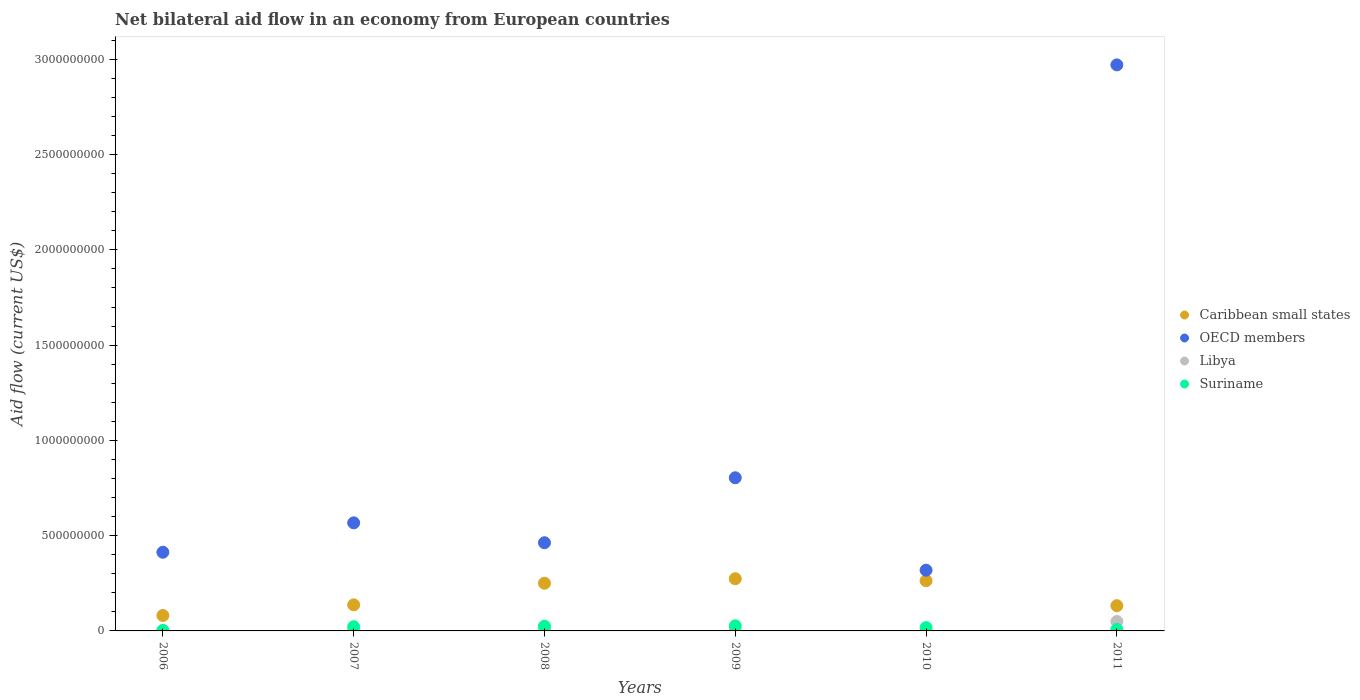How many different coloured dotlines are there?
Ensure brevity in your answer.  4. Is the number of dotlines equal to the number of legend labels?
Provide a succinct answer. Yes. What is the net bilateral aid flow in Libya in 2006?
Offer a very short reply. 8.10e+05. Across all years, what is the maximum net bilateral aid flow in Libya?
Your answer should be compact. 4.94e+07. Across all years, what is the minimum net bilateral aid flow in OECD members?
Provide a succinct answer. 3.19e+08. In which year was the net bilateral aid flow in Libya maximum?
Offer a terse response. 2011. In which year was the net bilateral aid flow in Suriname minimum?
Give a very brief answer. 2006. What is the total net bilateral aid flow in Libya in the graph?
Your answer should be compact. 5.89e+07. What is the difference between the net bilateral aid flow in Caribbean small states in 2007 and that in 2009?
Ensure brevity in your answer.  -1.37e+08. What is the difference between the net bilateral aid flow in Caribbean small states in 2007 and the net bilateral aid flow in Suriname in 2008?
Provide a succinct answer. 1.12e+08. What is the average net bilateral aid flow in Libya per year?
Provide a short and direct response. 9.82e+06. In the year 2007, what is the difference between the net bilateral aid flow in Suriname and net bilateral aid flow in Libya?
Provide a short and direct response. 2.09e+07. What is the ratio of the net bilateral aid flow in Libya in 2006 to that in 2009?
Your answer should be compact. 0.37. Is the net bilateral aid flow in OECD members in 2010 less than that in 2011?
Your answer should be very brief. Yes. Is the difference between the net bilateral aid flow in Suriname in 2008 and 2011 greater than the difference between the net bilateral aid flow in Libya in 2008 and 2011?
Give a very brief answer. Yes. What is the difference between the highest and the second highest net bilateral aid flow in Caribbean small states?
Give a very brief answer. 1.02e+07. What is the difference between the highest and the lowest net bilateral aid flow in Suriname?
Provide a succinct answer. 2.42e+07. Is the sum of the net bilateral aid flow in OECD members in 2007 and 2009 greater than the maximum net bilateral aid flow in Suriname across all years?
Give a very brief answer. Yes. Is it the case that in every year, the sum of the net bilateral aid flow in OECD members and net bilateral aid flow in Libya  is greater than the sum of net bilateral aid flow in Suriname and net bilateral aid flow in Caribbean small states?
Offer a very short reply. Yes. Is the net bilateral aid flow in OECD members strictly less than the net bilateral aid flow in Caribbean small states over the years?
Ensure brevity in your answer.  No. Does the graph contain grids?
Offer a very short reply. No. Where does the legend appear in the graph?
Offer a very short reply. Center right. What is the title of the graph?
Your answer should be very brief. Net bilateral aid flow in an economy from European countries. Does "Europe(all income levels)" appear as one of the legend labels in the graph?
Provide a succinct answer. No. What is the Aid flow (current US$) in Caribbean small states in 2006?
Your answer should be very brief. 8.10e+07. What is the Aid flow (current US$) of OECD members in 2006?
Keep it short and to the point. 4.13e+08. What is the Aid flow (current US$) of Libya in 2006?
Give a very brief answer. 8.10e+05. What is the Aid flow (current US$) in Suriname in 2006?
Your response must be concise. 2.58e+06. What is the Aid flow (current US$) of Caribbean small states in 2007?
Keep it short and to the point. 1.37e+08. What is the Aid flow (current US$) in OECD members in 2007?
Your answer should be compact. 5.67e+08. What is the Aid flow (current US$) in Libya in 2007?
Provide a succinct answer. 1.12e+06. What is the Aid flow (current US$) of Suriname in 2007?
Offer a terse response. 2.20e+07. What is the Aid flow (current US$) of Caribbean small states in 2008?
Offer a very short reply. 2.50e+08. What is the Aid flow (current US$) of OECD members in 2008?
Give a very brief answer. 4.63e+08. What is the Aid flow (current US$) of Libya in 2008?
Your answer should be very brief. 4.29e+06. What is the Aid flow (current US$) in Suriname in 2008?
Your answer should be very brief. 2.47e+07. What is the Aid flow (current US$) in Caribbean small states in 2009?
Offer a terse response. 2.74e+08. What is the Aid flow (current US$) of OECD members in 2009?
Your answer should be very brief. 8.04e+08. What is the Aid flow (current US$) in Libya in 2009?
Offer a very short reply. 2.17e+06. What is the Aid flow (current US$) of Suriname in 2009?
Keep it short and to the point. 2.68e+07. What is the Aid flow (current US$) in Caribbean small states in 2010?
Ensure brevity in your answer.  2.64e+08. What is the Aid flow (current US$) of OECD members in 2010?
Ensure brevity in your answer.  3.19e+08. What is the Aid flow (current US$) in Libya in 2010?
Keep it short and to the point. 1.06e+06. What is the Aid flow (current US$) of Suriname in 2010?
Your answer should be compact. 1.74e+07. What is the Aid flow (current US$) of Caribbean small states in 2011?
Your answer should be very brief. 1.32e+08. What is the Aid flow (current US$) in OECD members in 2011?
Offer a very short reply. 2.97e+09. What is the Aid flow (current US$) of Libya in 2011?
Offer a terse response. 4.94e+07. What is the Aid flow (current US$) of Suriname in 2011?
Keep it short and to the point. 7.56e+06. Across all years, what is the maximum Aid flow (current US$) in Caribbean small states?
Make the answer very short. 2.74e+08. Across all years, what is the maximum Aid flow (current US$) of OECD members?
Provide a succinct answer. 2.97e+09. Across all years, what is the maximum Aid flow (current US$) of Libya?
Offer a very short reply. 4.94e+07. Across all years, what is the maximum Aid flow (current US$) of Suriname?
Give a very brief answer. 2.68e+07. Across all years, what is the minimum Aid flow (current US$) of Caribbean small states?
Your response must be concise. 8.10e+07. Across all years, what is the minimum Aid flow (current US$) of OECD members?
Offer a very short reply. 3.19e+08. Across all years, what is the minimum Aid flow (current US$) of Libya?
Your answer should be very brief. 8.10e+05. Across all years, what is the minimum Aid flow (current US$) in Suriname?
Your answer should be compact. 2.58e+06. What is the total Aid flow (current US$) in Caribbean small states in the graph?
Offer a very short reply. 1.14e+09. What is the total Aid flow (current US$) in OECD members in the graph?
Offer a terse response. 5.54e+09. What is the total Aid flow (current US$) in Libya in the graph?
Offer a terse response. 5.89e+07. What is the total Aid flow (current US$) of Suriname in the graph?
Ensure brevity in your answer.  1.01e+08. What is the difference between the Aid flow (current US$) in Caribbean small states in 2006 and that in 2007?
Provide a short and direct response. -5.58e+07. What is the difference between the Aid flow (current US$) of OECD members in 2006 and that in 2007?
Offer a terse response. -1.54e+08. What is the difference between the Aid flow (current US$) of Libya in 2006 and that in 2007?
Give a very brief answer. -3.10e+05. What is the difference between the Aid flow (current US$) in Suriname in 2006 and that in 2007?
Provide a succinct answer. -1.95e+07. What is the difference between the Aid flow (current US$) in Caribbean small states in 2006 and that in 2008?
Your answer should be compact. -1.69e+08. What is the difference between the Aid flow (current US$) in OECD members in 2006 and that in 2008?
Your answer should be compact. -4.98e+07. What is the difference between the Aid flow (current US$) of Libya in 2006 and that in 2008?
Ensure brevity in your answer.  -3.48e+06. What is the difference between the Aid flow (current US$) of Suriname in 2006 and that in 2008?
Offer a very short reply. -2.21e+07. What is the difference between the Aid flow (current US$) in Caribbean small states in 2006 and that in 2009?
Your response must be concise. -1.93e+08. What is the difference between the Aid flow (current US$) of OECD members in 2006 and that in 2009?
Your response must be concise. -3.91e+08. What is the difference between the Aid flow (current US$) of Libya in 2006 and that in 2009?
Your answer should be very brief. -1.36e+06. What is the difference between the Aid flow (current US$) of Suriname in 2006 and that in 2009?
Make the answer very short. -2.42e+07. What is the difference between the Aid flow (current US$) in Caribbean small states in 2006 and that in 2010?
Your answer should be very brief. -1.83e+08. What is the difference between the Aid flow (current US$) in OECD members in 2006 and that in 2010?
Offer a very short reply. 9.41e+07. What is the difference between the Aid flow (current US$) of Suriname in 2006 and that in 2010?
Ensure brevity in your answer.  -1.48e+07. What is the difference between the Aid flow (current US$) of Caribbean small states in 2006 and that in 2011?
Keep it short and to the point. -5.14e+07. What is the difference between the Aid flow (current US$) in OECD members in 2006 and that in 2011?
Offer a terse response. -2.56e+09. What is the difference between the Aid flow (current US$) in Libya in 2006 and that in 2011?
Ensure brevity in your answer.  -4.86e+07. What is the difference between the Aid flow (current US$) of Suriname in 2006 and that in 2011?
Your answer should be very brief. -4.98e+06. What is the difference between the Aid flow (current US$) of Caribbean small states in 2007 and that in 2008?
Ensure brevity in your answer.  -1.13e+08. What is the difference between the Aid flow (current US$) of OECD members in 2007 and that in 2008?
Provide a succinct answer. 1.04e+08. What is the difference between the Aid flow (current US$) of Libya in 2007 and that in 2008?
Provide a succinct answer. -3.17e+06. What is the difference between the Aid flow (current US$) of Suriname in 2007 and that in 2008?
Your answer should be very brief. -2.66e+06. What is the difference between the Aid flow (current US$) in Caribbean small states in 2007 and that in 2009?
Provide a short and direct response. -1.37e+08. What is the difference between the Aid flow (current US$) of OECD members in 2007 and that in 2009?
Keep it short and to the point. -2.37e+08. What is the difference between the Aid flow (current US$) of Libya in 2007 and that in 2009?
Offer a terse response. -1.05e+06. What is the difference between the Aid flow (current US$) of Suriname in 2007 and that in 2009?
Offer a terse response. -4.75e+06. What is the difference between the Aid flow (current US$) in Caribbean small states in 2007 and that in 2010?
Provide a succinct answer. -1.27e+08. What is the difference between the Aid flow (current US$) of OECD members in 2007 and that in 2010?
Offer a very short reply. 2.48e+08. What is the difference between the Aid flow (current US$) in Suriname in 2007 and that in 2010?
Give a very brief answer. 4.70e+06. What is the difference between the Aid flow (current US$) in Caribbean small states in 2007 and that in 2011?
Your answer should be compact. 4.43e+06. What is the difference between the Aid flow (current US$) in OECD members in 2007 and that in 2011?
Provide a short and direct response. -2.40e+09. What is the difference between the Aid flow (current US$) of Libya in 2007 and that in 2011?
Provide a short and direct response. -4.83e+07. What is the difference between the Aid flow (current US$) in Suriname in 2007 and that in 2011?
Make the answer very short. 1.45e+07. What is the difference between the Aid flow (current US$) in Caribbean small states in 2008 and that in 2009?
Keep it short and to the point. -2.37e+07. What is the difference between the Aid flow (current US$) of OECD members in 2008 and that in 2009?
Your response must be concise. -3.41e+08. What is the difference between the Aid flow (current US$) of Libya in 2008 and that in 2009?
Make the answer very short. 2.12e+06. What is the difference between the Aid flow (current US$) of Suriname in 2008 and that in 2009?
Make the answer very short. -2.09e+06. What is the difference between the Aid flow (current US$) of Caribbean small states in 2008 and that in 2010?
Ensure brevity in your answer.  -1.34e+07. What is the difference between the Aid flow (current US$) in OECD members in 2008 and that in 2010?
Provide a short and direct response. 1.44e+08. What is the difference between the Aid flow (current US$) in Libya in 2008 and that in 2010?
Give a very brief answer. 3.23e+06. What is the difference between the Aid flow (current US$) of Suriname in 2008 and that in 2010?
Keep it short and to the point. 7.36e+06. What is the difference between the Aid flow (current US$) in Caribbean small states in 2008 and that in 2011?
Your response must be concise. 1.18e+08. What is the difference between the Aid flow (current US$) in OECD members in 2008 and that in 2011?
Ensure brevity in your answer.  -2.51e+09. What is the difference between the Aid flow (current US$) of Libya in 2008 and that in 2011?
Provide a succinct answer. -4.52e+07. What is the difference between the Aid flow (current US$) in Suriname in 2008 and that in 2011?
Keep it short and to the point. 1.72e+07. What is the difference between the Aid flow (current US$) in Caribbean small states in 2009 and that in 2010?
Give a very brief answer. 1.02e+07. What is the difference between the Aid flow (current US$) of OECD members in 2009 and that in 2010?
Offer a very short reply. 4.85e+08. What is the difference between the Aid flow (current US$) of Libya in 2009 and that in 2010?
Give a very brief answer. 1.11e+06. What is the difference between the Aid flow (current US$) in Suriname in 2009 and that in 2010?
Keep it short and to the point. 9.45e+06. What is the difference between the Aid flow (current US$) of Caribbean small states in 2009 and that in 2011?
Make the answer very short. 1.42e+08. What is the difference between the Aid flow (current US$) in OECD members in 2009 and that in 2011?
Your response must be concise. -2.17e+09. What is the difference between the Aid flow (current US$) of Libya in 2009 and that in 2011?
Offer a terse response. -4.73e+07. What is the difference between the Aid flow (current US$) in Suriname in 2009 and that in 2011?
Your answer should be very brief. 1.92e+07. What is the difference between the Aid flow (current US$) of Caribbean small states in 2010 and that in 2011?
Your answer should be very brief. 1.31e+08. What is the difference between the Aid flow (current US$) in OECD members in 2010 and that in 2011?
Your answer should be compact. -2.65e+09. What is the difference between the Aid flow (current US$) of Libya in 2010 and that in 2011?
Offer a very short reply. -4.84e+07. What is the difference between the Aid flow (current US$) of Suriname in 2010 and that in 2011?
Make the answer very short. 9.79e+06. What is the difference between the Aid flow (current US$) in Caribbean small states in 2006 and the Aid flow (current US$) in OECD members in 2007?
Provide a short and direct response. -4.86e+08. What is the difference between the Aid flow (current US$) in Caribbean small states in 2006 and the Aid flow (current US$) in Libya in 2007?
Ensure brevity in your answer.  7.99e+07. What is the difference between the Aid flow (current US$) of Caribbean small states in 2006 and the Aid flow (current US$) of Suriname in 2007?
Your response must be concise. 5.89e+07. What is the difference between the Aid flow (current US$) of OECD members in 2006 and the Aid flow (current US$) of Libya in 2007?
Provide a succinct answer. 4.12e+08. What is the difference between the Aid flow (current US$) in OECD members in 2006 and the Aid flow (current US$) in Suriname in 2007?
Offer a terse response. 3.91e+08. What is the difference between the Aid flow (current US$) of Libya in 2006 and the Aid flow (current US$) of Suriname in 2007?
Your answer should be compact. -2.12e+07. What is the difference between the Aid flow (current US$) of Caribbean small states in 2006 and the Aid flow (current US$) of OECD members in 2008?
Provide a succinct answer. -3.82e+08. What is the difference between the Aid flow (current US$) of Caribbean small states in 2006 and the Aid flow (current US$) of Libya in 2008?
Your response must be concise. 7.67e+07. What is the difference between the Aid flow (current US$) of Caribbean small states in 2006 and the Aid flow (current US$) of Suriname in 2008?
Provide a short and direct response. 5.63e+07. What is the difference between the Aid flow (current US$) of OECD members in 2006 and the Aid flow (current US$) of Libya in 2008?
Your answer should be compact. 4.09e+08. What is the difference between the Aid flow (current US$) of OECD members in 2006 and the Aid flow (current US$) of Suriname in 2008?
Provide a succinct answer. 3.88e+08. What is the difference between the Aid flow (current US$) in Libya in 2006 and the Aid flow (current US$) in Suriname in 2008?
Offer a very short reply. -2.39e+07. What is the difference between the Aid flow (current US$) in Caribbean small states in 2006 and the Aid flow (current US$) in OECD members in 2009?
Your answer should be compact. -7.23e+08. What is the difference between the Aid flow (current US$) of Caribbean small states in 2006 and the Aid flow (current US$) of Libya in 2009?
Make the answer very short. 7.88e+07. What is the difference between the Aid flow (current US$) of Caribbean small states in 2006 and the Aid flow (current US$) of Suriname in 2009?
Your answer should be very brief. 5.42e+07. What is the difference between the Aid flow (current US$) of OECD members in 2006 and the Aid flow (current US$) of Libya in 2009?
Your answer should be compact. 4.11e+08. What is the difference between the Aid flow (current US$) of OECD members in 2006 and the Aid flow (current US$) of Suriname in 2009?
Your response must be concise. 3.86e+08. What is the difference between the Aid flow (current US$) of Libya in 2006 and the Aid flow (current US$) of Suriname in 2009?
Your answer should be compact. -2.60e+07. What is the difference between the Aid flow (current US$) in Caribbean small states in 2006 and the Aid flow (current US$) in OECD members in 2010?
Provide a short and direct response. -2.38e+08. What is the difference between the Aid flow (current US$) in Caribbean small states in 2006 and the Aid flow (current US$) in Libya in 2010?
Provide a short and direct response. 7.99e+07. What is the difference between the Aid flow (current US$) of Caribbean small states in 2006 and the Aid flow (current US$) of Suriname in 2010?
Your response must be concise. 6.36e+07. What is the difference between the Aid flow (current US$) of OECD members in 2006 and the Aid flow (current US$) of Libya in 2010?
Give a very brief answer. 4.12e+08. What is the difference between the Aid flow (current US$) of OECD members in 2006 and the Aid flow (current US$) of Suriname in 2010?
Your response must be concise. 3.96e+08. What is the difference between the Aid flow (current US$) in Libya in 2006 and the Aid flow (current US$) in Suriname in 2010?
Provide a short and direct response. -1.65e+07. What is the difference between the Aid flow (current US$) of Caribbean small states in 2006 and the Aid flow (current US$) of OECD members in 2011?
Your answer should be very brief. -2.89e+09. What is the difference between the Aid flow (current US$) in Caribbean small states in 2006 and the Aid flow (current US$) in Libya in 2011?
Your response must be concise. 3.16e+07. What is the difference between the Aid flow (current US$) of Caribbean small states in 2006 and the Aid flow (current US$) of Suriname in 2011?
Offer a terse response. 7.34e+07. What is the difference between the Aid flow (current US$) of OECD members in 2006 and the Aid flow (current US$) of Libya in 2011?
Provide a succinct answer. 3.64e+08. What is the difference between the Aid flow (current US$) in OECD members in 2006 and the Aid flow (current US$) in Suriname in 2011?
Provide a short and direct response. 4.05e+08. What is the difference between the Aid flow (current US$) of Libya in 2006 and the Aid flow (current US$) of Suriname in 2011?
Make the answer very short. -6.75e+06. What is the difference between the Aid flow (current US$) in Caribbean small states in 2007 and the Aid flow (current US$) in OECD members in 2008?
Make the answer very short. -3.26e+08. What is the difference between the Aid flow (current US$) in Caribbean small states in 2007 and the Aid flow (current US$) in Libya in 2008?
Give a very brief answer. 1.33e+08. What is the difference between the Aid flow (current US$) in Caribbean small states in 2007 and the Aid flow (current US$) in Suriname in 2008?
Ensure brevity in your answer.  1.12e+08. What is the difference between the Aid flow (current US$) of OECD members in 2007 and the Aid flow (current US$) of Libya in 2008?
Your response must be concise. 5.63e+08. What is the difference between the Aid flow (current US$) of OECD members in 2007 and the Aid flow (current US$) of Suriname in 2008?
Make the answer very short. 5.43e+08. What is the difference between the Aid flow (current US$) of Libya in 2007 and the Aid flow (current US$) of Suriname in 2008?
Your answer should be compact. -2.36e+07. What is the difference between the Aid flow (current US$) in Caribbean small states in 2007 and the Aid flow (current US$) in OECD members in 2009?
Offer a terse response. -6.67e+08. What is the difference between the Aid flow (current US$) in Caribbean small states in 2007 and the Aid flow (current US$) in Libya in 2009?
Your response must be concise. 1.35e+08. What is the difference between the Aid flow (current US$) of Caribbean small states in 2007 and the Aid flow (current US$) of Suriname in 2009?
Provide a succinct answer. 1.10e+08. What is the difference between the Aid flow (current US$) in OECD members in 2007 and the Aid flow (current US$) in Libya in 2009?
Offer a very short reply. 5.65e+08. What is the difference between the Aid flow (current US$) of OECD members in 2007 and the Aid flow (current US$) of Suriname in 2009?
Your answer should be compact. 5.40e+08. What is the difference between the Aid flow (current US$) in Libya in 2007 and the Aid flow (current US$) in Suriname in 2009?
Offer a terse response. -2.57e+07. What is the difference between the Aid flow (current US$) in Caribbean small states in 2007 and the Aid flow (current US$) in OECD members in 2010?
Provide a short and direct response. -1.82e+08. What is the difference between the Aid flow (current US$) in Caribbean small states in 2007 and the Aid flow (current US$) in Libya in 2010?
Offer a terse response. 1.36e+08. What is the difference between the Aid flow (current US$) in Caribbean small states in 2007 and the Aid flow (current US$) in Suriname in 2010?
Your response must be concise. 1.19e+08. What is the difference between the Aid flow (current US$) of OECD members in 2007 and the Aid flow (current US$) of Libya in 2010?
Ensure brevity in your answer.  5.66e+08. What is the difference between the Aid flow (current US$) of OECD members in 2007 and the Aid flow (current US$) of Suriname in 2010?
Your answer should be compact. 5.50e+08. What is the difference between the Aid flow (current US$) in Libya in 2007 and the Aid flow (current US$) in Suriname in 2010?
Ensure brevity in your answer.  -1.62e+07. What is the difference between the Aid flow (current US$) in Caribbean small states in 2007 and the Aid flow (current US$) in OECD members in 2011?
Keep it short and to the point. -2.83e+09. What is the difference between the Aid flow (current US$) in Caribbean small states in 2007 and the Aid flow (current US$) in Libya in 2011?
Your response must be concise. 8.74e+07. What is the difference between the Aid flow (current US$) of Caribbean small states in 2007 and the Aid flow (current US$) of Suriname in 2011?
Keep it short and to the point. 1.29e+08. What is the difference between the Aid flow (current US$) of OECD members in 2007 and the Aid flow (current US$) of Libya in 2011?
Your response must be concise. 5.18e+08. What is the difference between the Aid flow (current US$) of OECD members in 2007 and the Aid flow (current US$) of Suriname in 2011?
Ensure brevity in your answer.  5.60e+08. What is the difference between the Aid flow (current US$) in Libya in 2007 and the Aid flow (current US$) in Suriname in 2011?
Your response must be concise. -6.44e+06. What is the difference between the Aid flow (current US$) in Caribbean small states in 2008 and the Aid flow (current US$) in OECD members in 2009?
Your response must be concise. -5.54e+08. What is the difference between the Aid flow (current US$) in Caribbean small states in 2008 and the Aid flow (current US$) in Libya in 2009?
Provide a succinct answer. 2.48e+08. What is the difference between the Aid flow (current US$) of Caribbean small states in 2008 and the Aid flow (current US$) of Suriname in 2009?
Make the answer very short. 2.24e+08. What is the difference between the Aid flow (current US$) in OECD members in 2008 and the Aid flow (current US$) in Libya in 2009?
Your response must be concise. 4.61e+08. What is the difference between the Aid flow (current US$) in OECD members in 2008 and the Aid flow (current US$) in Suriname in 2009?
Offer a very short reply. 4.36e+08. What is the difference between the Aid flow (current US$) of Libya in 2008 and the Aid flow (current US$) of Suriname in 2009?
Provide a succinct answer. -2.25e+07. What is the difference between the Aid flow (current US$) of Caribbean small states in 2008 and the Aid flow (current US$) of OECD members in 2010?
Make the answer very short. -6.85e+07. What is the difference between the Aid flow (current US$) in Caribbean small states in 2008 and the Aid flow (current US$) in Libya in 2010?
Keep it short and to the point. 2.49e+08. What is the difference between the Aid flow (current US$) of Caribbean small states in 2008 and the Aid flow (current US$) of Suriname in 2010?
Offer a very short reply. 2.33e+08. What is the difference between the Aid flow (current US$) of OECD members in 2008 and the Aid flow (current US$) of Libya in 2010?
Your response must be concise. 4.62e+08. What is the difference between the Aid flow (current US$) in OECD members in 2008 and the Aid flow (current US$) in Suriname in 2010?
Offer a terse response. 4.45e+08. What is the difference between the Aid flow (current US$) of Libya in 2008 and the Aid flow (current US$) of Suriname in 2010?
Your answer should be compact. -1.31e+07. What is the difference between the Aid flow (current US$) in Caribbean small states in 2008 and the Aid flow (current US$) in OECD members in 2011?
Your response must be concise. -2.72e+09. What is the difference between the Aid flow (current US$) of Caribbean small states in 2008 and the Aid flow (current US$) of Libya in 2011?
Offer a very short reply. 2.01e+08. What is the difference between the Aid flow (current US$) in Caribbean small states in 2008 and the Aid flow (current US$) in Suriname in 2011?
Make the answer very short. 2.43e+08. What is the difference between the Aid flow (current US$) in OECD members in 2008 and the Aid flow (current US$) in Libya in 2011?
Provide a short and direct response. 4.13e+08. What is the difference between the Aid flow (current US$) in OECD members in 2008 and the Aid flow (current US$) in Suriname in 2011?
Offer a terse response. 4.55e+08. What is the difference between the Aid flow (current US$) of Libya in 2008 and the Aid flow (current US$) of Suriname in 2011?
Your response must be concise. -3.27e+06. What is the difference between the Aid flow (current US$) in Caribbean small states in 2009 and the Aid flow (current US$) in OECD members in 2010?
Make the answer very short. -4.48e+07. What is the difference between the Aid flow (current US$) of Caribbean small states in 2009 and the Aid flow (current US$) of Libya in 2010?
Keep it short and to the point. 2.73e+08. What is the difference between the Aid flow (current US$) of Caribbean small states in 2009 and the Aid flow (current US$) of Suriname in 2010?
Ensure brevity in your answer.  2.57e+08. What is the difference between the Aid flow (current US$) of OECD members in 2009 and the Aid flow (current US$) of Libya in 2010?
Provide a short and direct response. 8.03e+08. What is the difference between the Aid flow (current US$) of OECD members in 2009 and the Aid flow (current US$) of Suriname in 2010?
Provide a short and direct response. 7.86e+08. What is the difference between the Aid flow (current US$) of Libya in 2009 and the Aid flow (current US$) of Suriname in 2010?
Provide a succinct answer. -1.52e+07. What is the difference between the Aid flow (current US$) in Caribbean small states in 2009 and the Aid flow (current US$) in OECD members in 2011?
Your answer should be compact. -2.70e+09. What is the difference between the Aid flow (current US$) of Caribbean small states in 2009 and the Aid flow (current US$) of Libya in 2011?
Give a very brief answer. 2.25e+08. What is the difference between the Aid flow (current US$) in Caribbean small states in 2009 and the Aid flow (current US$) in Suriname in 2011?
Provide a short and direct response. 2.66e+08. What is the difference between the Aid flow (current US$) of OECD members in 2009 and the Aid flow (current US$) of Libya in 2011?
Make the answer very short. 7.54e+08. What is the difference between the Aid flow (current US$) of OECD members in 2009 and the Aid flow (current US$) of Suriname in 2011?
Keep it short and to the point. 7.96e+08. What is the difference between the Aid flow (current US$) in Libya in 2009 and the Aid flow (current US$) in Suriname in 2011?
Your response must be concise. -5.39e+06. What is the difference between the Aid flow (current US$) of Caribbean small states in 2010 and the Aid flow (current US$) of OECD members in 2011?
Ensure brevity in your answer.  -2.71e+09. What is the difference between the Aid flow (current US$) of Caribbean small states in 2010 and the Aid flow (current US$) of Libya in 2011?
Offer a very short reply. 2.14e+08. What is the difference between the Aid flow (current US$) of Caribbean small states in 2010 and the Aid flow (current US$) of Suriname in 2011?
Your answer should be compact. 2.56e+08. What is the difference between the Aid flow (current US$) of OECD members in 2010 and the Aid flow (current US$) of Libya in 2011?
Keep it short and to the point. 2.69e+08. What is the difference between the Aid flow (current US$) in OECD members in 2010 and the Aid flow (current US$) in Suriname in 2011?
Keep it short and to the point. 3.11e+08. What is the difference between the Aid flow (current US$) in Libya in 2010 and the Aid flow (current US$) in Suriname in 2011?
Offer a very short reply. -6.50e+06. What is the average Aid flow (current US$) in Caribbean small states per year?
Keep it short and to the point. 1.90e+08. What is the average Aid flow (current US$) in OECD members per year?
Your answer should be very brief. 9.23e+08. What is the average Aid flow (current US$) in Libya per year?
Offer a terse response. 9.82e+06. What is the average Aid flow (current US$) in Suriname per year?
Ensure brevity in your answer.  1.68e+07. In the year 2006, what is the difference between the Aid flow (current US$) of Caribbean small states and Aid flow (current US$) of OECD members?
Ensure brevity in your answer.  -3.32e+08. In the year 2006, what is the difference between the Aid flow (current US$) in Caribbean small states and Aid flow (current US$) in Libya?
Provide a succinct answer. 8.02e+07. In the year 2006, what is the difference between the Aid flow (current US$) in Caribbean small states and Aid flow (current US$) in Suriname?
Keep it short and to the point. 7.84e+07. In the year 2006, what is the difference between the Aid flow (current US$) in OECD members and Aid flow (current US$) in Libya?
Offer a very short reply. 4.12e+08. In the year 2006, what is the difference between the Aid flow (current US$) in OECD members and Aid flow (current US$) in Suriname?
Ensure brevity in your answer.  4.10e+08. In the year 2006, what is the difference between the Aid flow (current US$) of Libya and Aid flow (current US$) of Suriname?
Your response must be concise. -1.77e+06. In the year 2007, what is the difference between the Aid flow (current US$) in Caribbean small states and Aid flow (current US$) in OECD members?
Provide a short and direct response. -4.30e+08. In the year 2007, what is the difference between the Aid flow (current US$) in Caribbean small states and Aid flow (current US$) in Libya?
Offer a terse response. 1.36e+08. In the year 2007, what is the difference between the Aid flow (current US$) of Caribbean small states and Aid flow (current US$) of Suriname?
Make the answer very short. 1.15e+08. In the year 2007, what is the difference between the Aid flow (current US$) of OECD members and Aid flow (current US$) of Libya?
Provide a short and direct response. 5.66e+08. In the year 2007, what is the difference between the Aid flow (current US$) of OECD members and Aid flow (current US$) of Suriname?
Make the answer very short. 5.45e+08. In the year 2007, what is the difference between the Aid flow (current US$) in Libya and Aid flow (current US$) in Suriname?
Your response must be concise. -2.09e+07. In the year 2008, what is the difference between the Aid flow (current US$) of Caribbean small states and Aid flow (current US$) of OECD members?
Keep it short and to the point. -2.12e+08. In the year 2008, what is the difference between the Aid flow (current US$) of Caribbean small states and Aid flow (current US$) of Libya?
Your answer should be compact. 2.46e+08. In the year 2008, what is the difference between the Aid flow (current US$) in Caribbean small states and Aid flow (current US$) in Suriname?
Provide a short and direct response. 2.26e+08. In the year 2008, what is the difference between the Aid flow (current US$) in OECD members and Aid flow (current US$) in Libya?
Make the answer very short. 4.58e+08. In the year 2008, what is the difference between the Aid flow (current US$) of OECD members and Aid flow (current US$) of Suriname?
Keep it short and to the point. 4.38e+08. In the year 2008, what is the difference between the Aid flow (current US$) of Libya and Aid flow (current US$) of Suriname?
Ensure brevity in your answer.  -2.04e+07. In the year 2009, what is the difference between the Aid flow (current US$) in Caribbean small states and Aid flow (current US$) in OECD members?
Offer a very short reply. -5.30e+08. In the year 2009, what is the difference between the Aid flow (current US$) of Caribbean small states and Aid flow (current US$) of Libya?
Ensure brevity in your answer.  2.72e+08. In the year 2009, what is the difference between the Aid flow (current US$) of Caribbean small states and Aid flow (current US$) of Suriname?
Provide a short and direct response. 2.47e+08. In the year 2009, what is the difference between the Aid flow (current US$) in OECD members and Aid flow (current US$) in Libya?
Offer a very short reply. 8.02e+08. In the year 2009, what is the difference between the Aid flow (current US$) in OECD members and Aid flow (current US$) in Suriname?
Offer a very short reply. 7.77e+08. In the year 2009, what is the difference between the Aid flow (current US$) of Libya and Aid flow (current US$) of Suriname?
Ensure brevity in your answer.  -2.46e+07. In the year 2010, what is the difference between the Aid flow (current US$) of Caribbean small states and Aid flow (current US$) of OECD members?
Your answer should be very brief. -5.51e+07. In the year 2010, what is the difference between the Aid flow (current US$) of Caribbean small states and Aid flow (current US$) of Libya?
Your answer should be compact. 2.63e+08. In the year 2010, what is the difference between the Aid flow (current US$) of Caribbean small states and Aid flow (current US$) of Suriname?
Keep it short and to the point. 2.46e+08. In the year 2010, what is the difference between the Aid flow (current US$) in OECD members and Aid flow (current US$) in Libya?
Your answer should be compact. 3.18e+08. In the year 2010, what is the difference between the Aid flow (current US$) of OECD members and Aid flow (current US$) of Suriname?
Provide a succinct answer. 3.01e+08. In the year 2010, what is the difference between the Aid flow (current US$) in Libya and Aid flow (current US$) in Suriname?
Provide a succinct answer. -1.63e+07. In the year 2011, what is the difference between the Aid flow (current US$) of Caribbean small states and Aid flow (current US$) of OECD members?
Your answer should be very brief. -2.84e+09. In the year 2011, what is the difference between the Aid flow (current US$) in Caribbean small states and Aid flow (current US$) in Libya?
Provide a succinct answer. 8.30e+07. In the year 2011, what is the difference between the Aid flow (current US$) of Caribbean small states and Aid flow (current US$) of Suriname?
Offer a very short reply. 1.25e+08. In the year 2011, what is the difference between the Aid flow (current US$) of OECD members and Aid flow (current US$) of Libya?
Offer a terse response. 2.92e+09. In the year 2011, what is the difference between the Aid flow (current US$) of OECD members and Aid flow (current US$) of Suriname?
Provide a succinct answer. 2.96e+09. In the year 2011, what is the difference between the Aid flow (current US$) of Libya and Aid flow (current US$) of Suriname?
Keep it short and to the point. 4.19e+07. What is the ratio of the Aid flow (current US$) in Caribbean small states in 2006 to that in 2007?
Offer a very short reply. 0.59. What is the ratio of the Aid flow (current US$) in OECD members in 2006 to that in 2007?
Make the answer very short. 0.73. What is the ratio of the Aid flow (current US$) in Libya in 2006 to that in 2007?
Provide a short and direct response. 0.72. What is the ratio of the Aid flow (current US$) of Suriname in 2006 to that in 2007?
Your answer should be very brief. 0.12. What is the ratio of the Aid flow (current US$) of Caribbean small states in 2006 to that in 2008?
Give a very brief answer. 0.32. What is the ratio of the Aid flow (current US$) of OECD members in 2006 to that in 2008?
Your answer should be very brief. 0.89. What is the ratio of the Aid flow (current US$) of Libya in 2006 to that in 2008?
Offer a very short reply. 0.19. What is the ratio of the Aid flow (current US$) in Suriname in 2006 to that in 2008?
Give a very brief answer. 0.1. What is the ratio of the Aid flow (current US$) of Caribbean small states in 2006 to that in 2009?
Give a very brief answer. 0.3. What is the ratio of the Aid flow (current US$) of OECD members in 2006 to that in 2009?
Your answer should be compact. 0.51. What is the ratio of the Aid flow (current US$) in Libya in 2006 to that in 2009?
Your response must be concise. 0.37. What is the ratio of the Aid flow (current US$) of Suriname in 2006 to that in 2009?
Make the answer very short. 0.1. What is the ratio of the Aid flow (current US$) in Caribbean small states in 2006 to that in 2010?
Give a very brief answer. 0.31. What is the ratio of the Aid flow (current US$) in OECD members in 2006 to that in 2010?
Provide a short and direct response. 1.3. What is the ratio of the Aid flow (current US$) of Libya in 2006 to that in 2010?
Your answer should be compact. 0.76. What is the ratio of the Aid flow (current US$) in Suriname in 2006 to that in 2010?
Give a very brief answer. 0.15. What is the ratio of the Aid flow (current US$) of Caribbean small states in 2006 to that in 2011?
Provide a short and direct response. 0.61. What is the ratio of the Aid flow (current US$) of OECD members in 2006 to that in 2011?
Give a very brief answer. 0.14. What is the ratio of the Aid flow (current US$) of Libya in 2006 to that in 2011?
Your response must be concise. 0.02. What is the ratio of the Aid flow (current US$) in Suriname in 2006 to that in 2011?
Ensure brevity in your answer.  0.34. What is the ratio of the Aid flow (current US$) of Caribbean small states in 2007 to that in 2008?
Provide a succinct answer. 0.55. What is the ratio of the Aid flow (current US$) of OECD members in 2007 to that in 2008?
Your response must be concise. 1.23. What is the ratio of the Aid flow (current US$) of Libya in 2007 to that in 2008?
Offer a very short reply. 0.26. What is the ratio of the Aid flow (current US$) in Suriname in 2007 to that in 2008?
Ensure brevity in your answer.  0.89. What is the ratio of the Aid flow (current US$) in Caribbean small states in 2007 to that in 2009?
Your answer should be very brief. 0.5. What is the ratio of the Aid flow (current US$) of OECD members in 2007 to that in 2009?
Make the answer very short. 0.71. What is the ratio of the Aid flow (current US$) of Libya in 2007 to that in 2009?
Ensure brevity in your answer.  0.52. What is the ratio of the Aid flow (current US$) in Suriname in 2007 to that in 2009?
Your answer should be compact. 0.82. What is the ratio of the Aid flow (current US$) in Caribbean small states in 2007 to that in 2010?
Keep it short and to the point. 0.52. What is the ratio of the Aid flow (current US$) of OECD members in 2007 to that in 2010?
Make the answer very short. 1.78. What is the ratio of the Aid flow (current US$) in Libya in 2007 to that in 2010?
Offer a very short reply. 1.06. What is the ratio of the Aid flow (current US$) in Suriname in 2007 to that in 2010?
Keep it short and to the point. 1.27. What is the ratio of the Aid flow (current US$) in Caribbean small states in 2007 to that in 2011?
Give a very brief answer. 1.03. What is the ratio of the Aid flow (current US$) in OECD members in 2007 to that in 2011?
Keep it short and to the point. 0.19. What is the ratio of the Aid flow (current US$) of Libya in 2007 to that in 2011?
Your response must be concise. 0.02. What is the ratio of the Aid flow (current US$) in Suriname in 2007 to that in 2011?
Give a very brief answer. 2.92. What is the ratio of the Aid flow (current US$) in Caribbean small states in 2008 to that in 2009?
Ensure brevity in your answer.  0.91. What is the ratio of the Aid flow (current US$) of OECD members in 2008 to that in 2009?
Offer a very short reply. 0.58. What is the ratio of the Aid flow (current US$) in Libya in 2008 to that in 2009?
Offer a very short reply. 1.98. What is the ratio of the Aid flow (current US$) in Suriname in 2008 to that in 2009?
Your response must be concise. 0.92. What is the ratio of the Aid flow (current US$) of Caribbean small states in 2008 to that in 2010?
Your answer should be compact. 0.95. What is the ratio of the Aid flow (current US$) in OECD members in 2008 to that in 2010?
Provide a short and direct response. 1.45. What is the ratio of the Aid flow (current US$) in Libya in 2008 to that in 2010?
Make the answer very short. 4.05. What is the ratio of the Aid flow (current US$) in Suriname in 2008 to that in 2010?
Make the answer very short. 1.42. What is the ratio of the Aid flow (current US$) of Caribbean small states in 2008 to that in 2011?
Ensure brevity in your answer.  1.89. What is the ratio of the Aid flow (current US$) in OECD members in 2008 to that in 2011?
Ensure brevity in your answer.  0.16. What is the ratio of the Aid flow (current US$) in Libya in 2008 to that in 2011?
Offer a very short reply. 0.09. What is the ratio of the Aid flow (current US$) of Suriname in 2008 to that in 2011?
Offer a very short reply. 3.27. What is the ratio of the Aid flow (current US$) in Caribbean small states in 2009 to that in 2010?
Ensure brevity in your answer.  1.04. What is the ratio of the Aid flow (current US$) of OECD members in 2009 to that in 2010?
Give a very brief answer. 2.52. What is the ratio of the Aid flow (current US$) in Libya in 2009 to that in 2010?
Provide a short and direct response. 2.05. What is the ratio of the Aid flow (current US$) of Suriname in 2009 to that in 2010?
Your response must be concise. 1.54. What is the ratio of the Aid flow (current US$) in Caribbean small states in 2009 to that in 2011?
Make the answer very short. 2.07. What is the ratio of the Aid flow (current US$) of OECD members in 2009 to that in 2011?
Provide a short and direct response. 0.27. What is the ratio of the Aid flow (current US$) in Libya in 2009 to that in 2011?
Your answer should be compact. 0.04. What is the ratio of the Aid flow (current US$) in Suriname in 2009 to that in 2011?
Make the answer very short. 3.54. What is the ratio of the Aid flow (current US$) of Caribbean small states in 2010 to that in 2011?
Offer a very short reply. 1.99. What is the ratio of the Aid flow (current US$) in OECD members in 2010 to that in 2011?
Offer a terse response. 0.11. What is the ratio of the Aid flow (current US$) of Libya in 2010 to that in 2011?
Offer a terse response. 0.02. What is the ratio of the Aid flow (current US$) in Suriname in 2010 to that in 2011?
Keep it short and to the point. 2.29. What is the difference between the highest and the second highest Aid flow (current US$) in Caribbean small states?
Give a very brief answer. 1.02e+07. What is the difference between the highest and the second highest Aid flow (current US$) in OECD members?
Make the answer very short. 2.17e+09. What is the difference between the highest and the second highest Aid flow (current US$) in Libya?
Offer a very short reply. 4.52e+07. What is the difference between the highest and the second highest Aid flow (current US$) in Suriname?
Your answer should be compact. 2.09e+06. What is the difference between the highest and the lowest Aid flow (current US$) in Caribbean small states?
Provide a short and direct response. 1.93e+08. What is the difference between the highest and the lowest Aid flow (current US$) in OECD members?
Your response must be concise. 2.65e+09. What is the difference between the highest and the lowest Aid flow (current US$) in Libya?
Make the answer very short. 4.86e+07. What is the difference between the highest and the lowest Aid flow (current US$) in Suriname?
Offer a very short reply. 2.42e+07. 